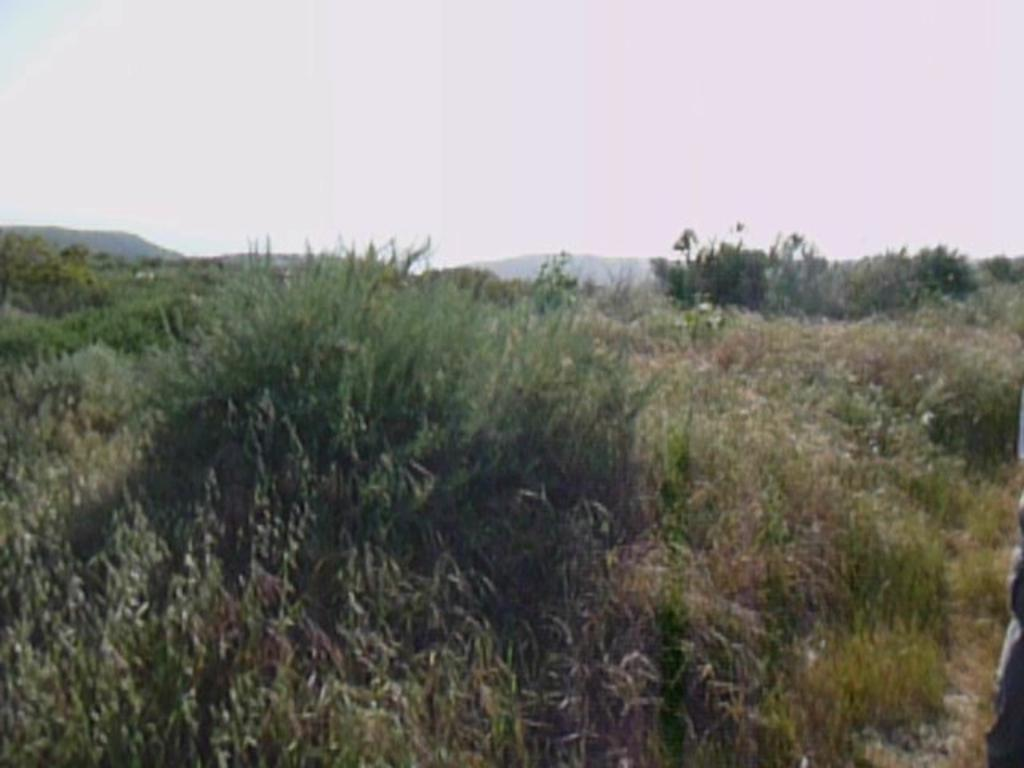What type of vegetation is present in the image? There is green grass in the image. What natural landforms can be seen in the image? There are mountains in the image. What colors are visible in the sky in the image? The sky is blue and white in color. How many houses are present in the image? There are no houses mentioned in the provided facts, so it cannot be determined from the image. 